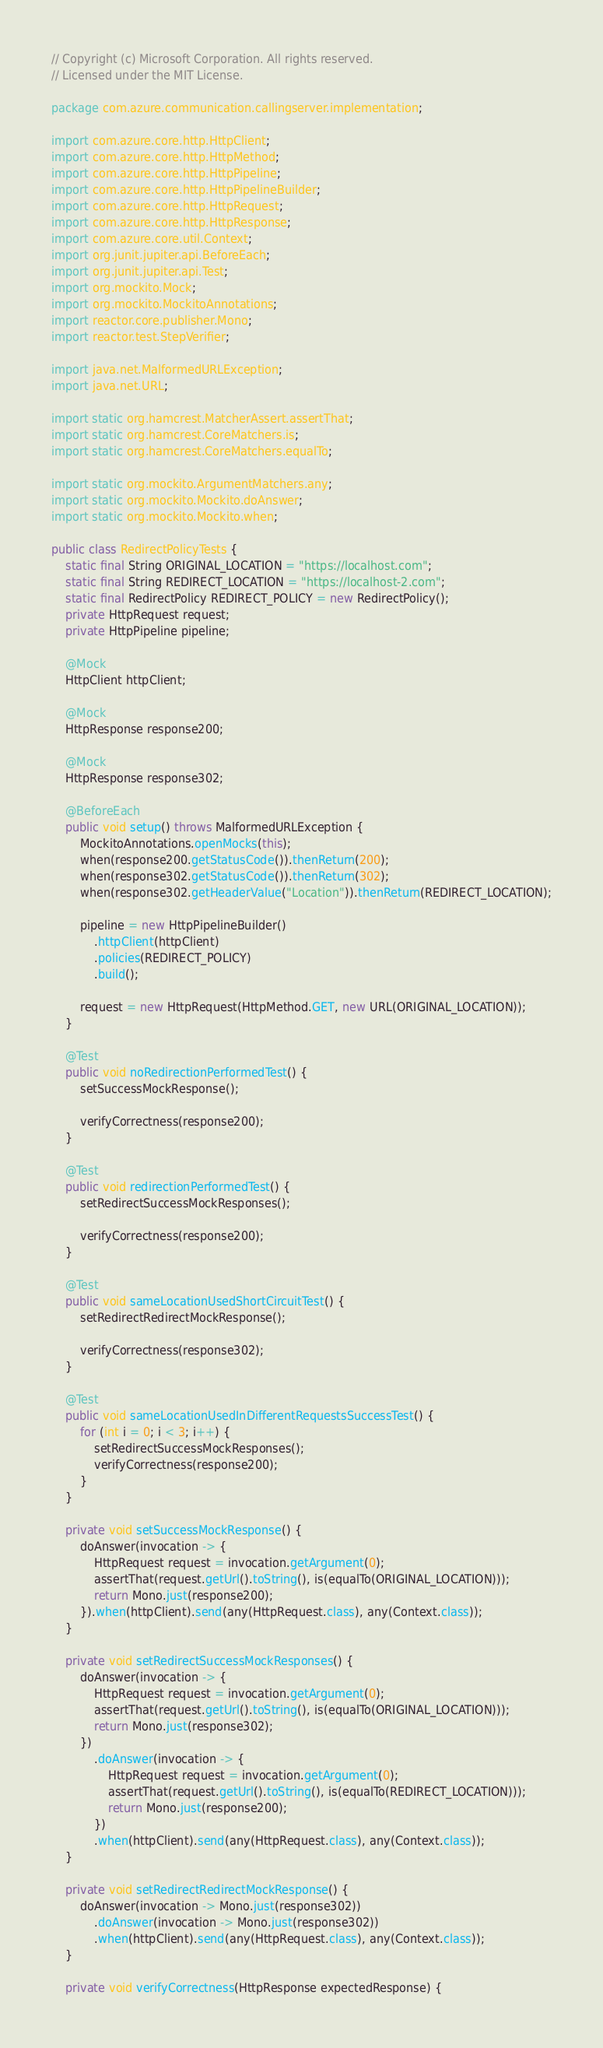<code> <loc_0><loc_0><loc_500><loc_500><_Java_>// Copyright (c) Microsoft Corporation. All rights reserved.
// Licensed under the MIT License.

package com.azure.communication.callingserver.implementation;

import com.azure.core.http.HttpClient;
import com.azure.core.http.HttpMethod;
import com.azure.core.http.HttpPipeline;
import com.azure.core.http.HttpPipelineBuilder;
import com.azure.core.http.HttpRequest;
import com.azure.core.http.HttpResponse;
import com.azure.core.util.Context;
import org.junit.jupiter.api.BeforeEach;
import org.junit.jupiter.api.Test;
import org.mockito.Mock;
import org.mockito.MockitoAnnotations;
import reactor.core.publisher.Mono;
import reactor.test.StepVerifier;

import java.net.MalformedURLException;
import java.net.URL;

import static org.hamcrest.MatcherAssert.assertThat;
import static org.hamcrest.CoreMatchers.is;
import static org.hamcrest.CoreMatchers.equalTo;

import static org.mockito.ArgumentMatchers.any;
import static org.mockito.Mockito.doAnswer;
import static org.mockito.Mockito.when;

public class RedirectPolicyTests {
    static final String ORIGINAL_LOCATION = "https://localhost.com";
    static final String REDIRECT_LOCATION = "https://localhost-2.com";
    static final RedirectPolicy REDIRECT_POLICY = new RedirectPolicy();
    private HttpRequest request;
    private HttpPipeline pipeline;

    @Mock
    HttpClient httpClient;

    @Mock
    HttpResponse response200;

    @Mock
    HttpResponse response302;

    @BeforeEach
    public void setup() throws MalformedURLException {
        MockitoAnnotations.openMocks(this);
        when(response200.getStatusCode()).thenReturn(200);
        when(response302.getStatusCode()).thenReturn(302);
        when(response302.getHeaderValue("Location")).thenReturn(REDIRECT_LOCATION);

        pipeline = new HttpPipelineBuilder()
            .httpClient(httpClient)
            .policies(REDIRECT_POLICY)
            .build();

        request = new HttpRequest(HttpMethod.GET, new URL(ORIGINAL_LOCATION));
    }

    @Test
    public void noRedirectionPerformedTest() {
        setSuccessMockResponse();

        verifyCorrectness(response200);
    }

    @Test
    public void redirectionPerformedTest() {
        setRedirectSuccessMockResponses();

        verifyCorrectness(response200);
    }

    @Test
    public void sameLocationUsedShortCircuitTest() {
        setRedirectRedirectMockResponse();

        verifyCorrectness(response302);
    }

    @Test
    public void sameLocationUsedInDifferentRequestsSuccessTest() {
        for (int i = 0; i < 3; i++) {
            setRedirectSuccessMockResponses();
            verifyCorrectness(response200);
        }
    }

    private void setSuccessMockResponse() {
        doAnswer(invocation -> {
            HttpRequest request = invocation.getArgument(0);
            assertThat(request.getUrl().toString(), is(equalTo(ORIGINAL_LOCATION)));
            return Mono.just(response200);
        }).when(httpClient).send(any(HttpRequest.class), any(Context.class));
    }

    private void setRedirectSuccessMockResponses() {
        doAnswer(invocation -> {
            HttpRequest request = invocation.getArgument(0);
            assertThat(request.getUrl().toString(), is(equalTo(ORIGINAL_LOCATION)));
            return Mono.just(response302);
        })
            .doAnswer(invocation -> {
                HttpRequest request = invocation.getArgument(0);
                assertThat(request.getUrl().toString(), is(equalTo(REDIRECT_LOCATION)));
                return Mono.just(response200);
            })
            .when(httpClient).send(any(HttpRequest.class), any(Context.class));
    }

    private void setRedirectRedirectMockResponse() {
        doAnswer(invocation -> Mono.just(response302))
            .doAnswer(invocation -> Mono.just(response302))
            .when(httpClient).send(any(HttpRequest.class), any(Context.class));
    }

    private void verifyCorrectness(HttpResponse expectedResponse) {</code> 